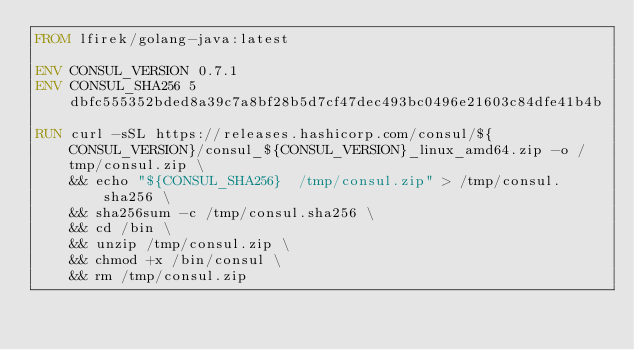<code> <loc_0><loc_0><loc_500><loc_500><_Dockerfile_>FROM lfirek/golang-java:latest

ENV CONSUL_VERSION 0.7.1
ENV CONSUL_SHA256 5dbfc555352bded8a39c7a8bf28b5d7cf47dec493bc0496e21603c84dfe41b4b

RUN curl -sSL https://releases.hashicorp.com/consul/${CONSUL_VERSION}/consul_${CONSUL_VERSION}_linux_amd64.zip -o /tmp/consul.zip \
    && echo "${CONSUL_SHA256}  /tmp/consul.zip" > /tmp/consul.sha256 \
    && sha256sum -c /tmp/consul.sha256 \
    && cd /bin \
    && unzip /tmp/consul.zip \
    && chmod +x /bin/consul \
    && rm /tmp/consul.zip
</code> 